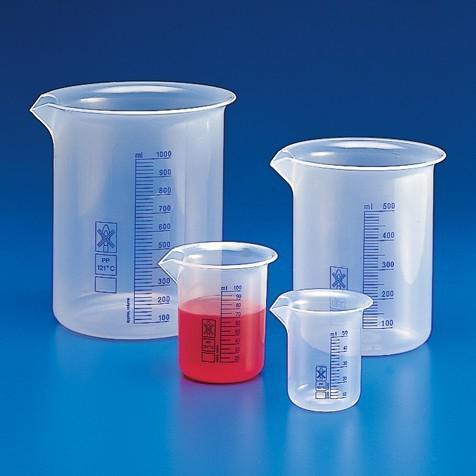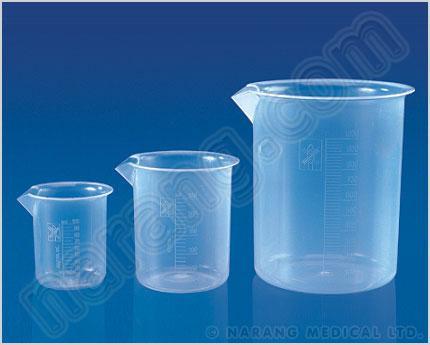The first image is the image on the left, the second image is the image on the right. For the images displayed, is the sentence "There are unfilled beakers." factually correct? Answer yes or no. Yes. The first image is the image on the left, the second image is the image on the right. Examine the images to the left and right. Is the description "In at least one image there are five beckers with only two full of blue liquid." accurate? Answer yes or no. No. 